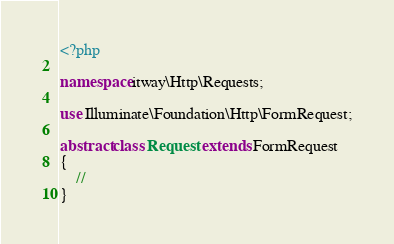Convert code to text. <code><loc_0><loc_0><loc_500><loc_500><_PHP_><?php

namespace itway\Http\Requests;

use Illuminate\Foundation\Http\FormRequest;

abstract class Request extends FormRequest
{
    //
}
</code> 